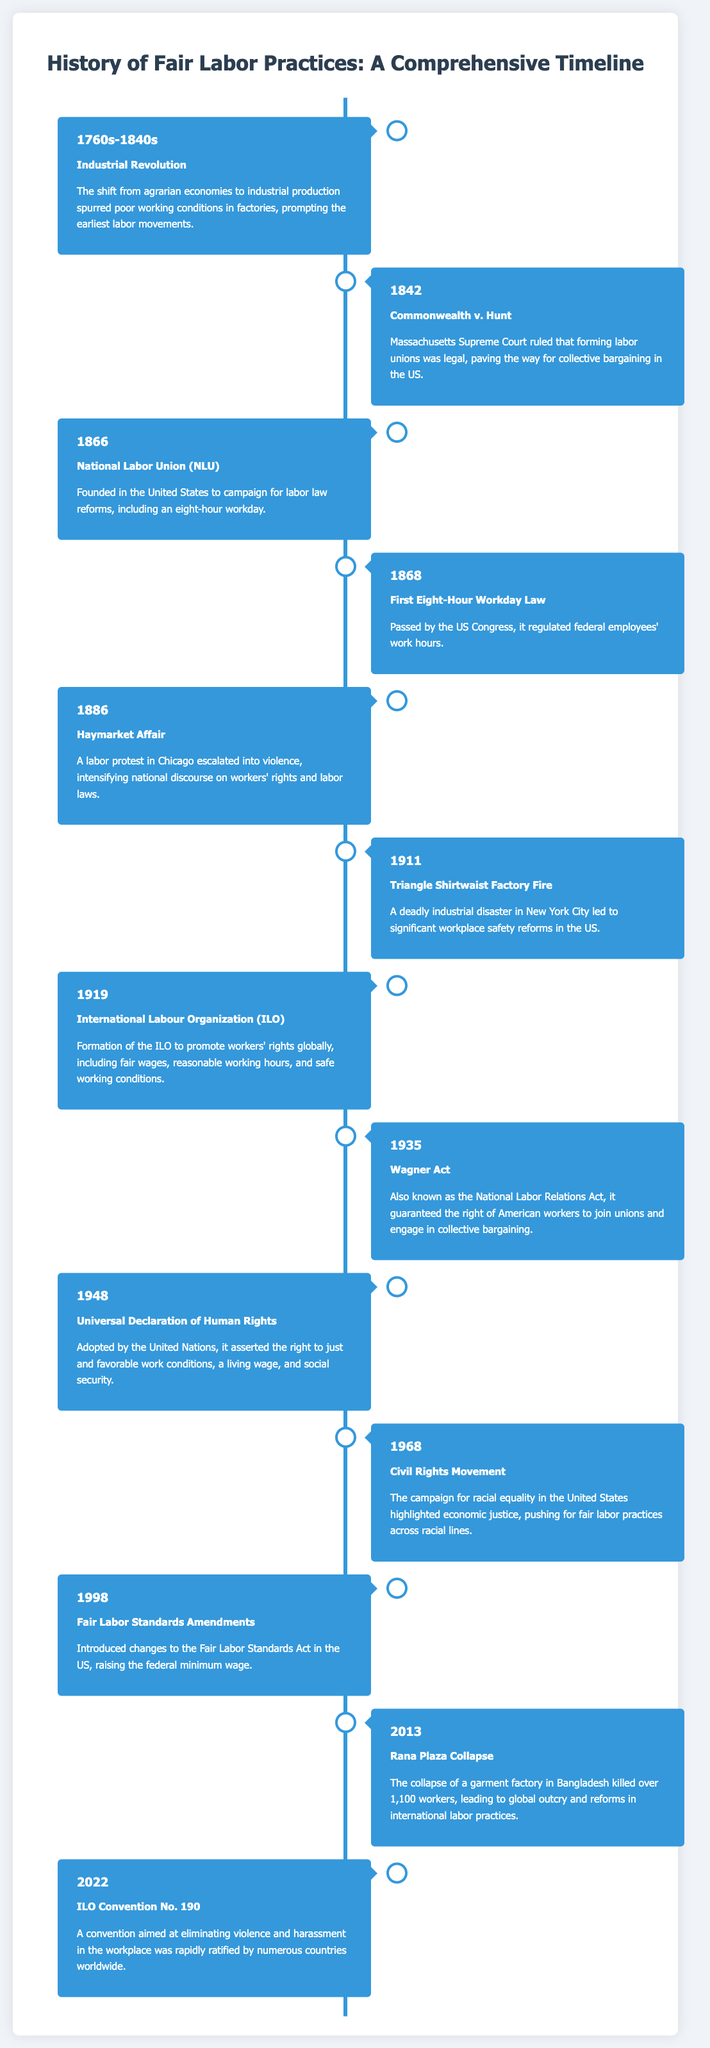What year did the Triangle Shirtwaist Factory Fire occur? The document lists the Triangle Shirtwaist Factory Fire in the year 1911.
Answer: 1911 What was the focus of the National Labor Union founded in 1866? The National Labor Union was focused on campaigning for labor law reforms, including an eight-hour workday.
Answer: Eight-hour workday Which event led to significant workplace safety reforms in the US? The Triangle Shirtwaist Factory Fire led to significant workplace safety reforms in the US according to the document.
Answer: Triangle Shirtwaist Factory Fire What legislation was passed in 1935 to guarantee workers' rights to unionize? The document indicates that the Wagner Act, also known as the National Labor Relations Act, was passed in 1935.
Answer: Wagner Act What international organization was formed in 1919? The International Labour Organization (ILO) was formed in 1919 as stated in the timeline.
Answer: International Labour Organization Which event in 2013 raised awareness of labor conditions worldwide? The Rana Plaza Collapse in Bangladesh caused global outcry and highlighted labor conditions.
Answer: Rana Plaza Collapse What does ILO Convention No. 190 aim to eliminate? The convention aims to eliminate violence and harassment in the workplace.
Answer: Violence and harassment What fundamental right was asserted in the Universal Declaration of Human Rights adopted in 1948? The document states that the Universal Declaration asserted the right to just and favorable work conditions.
Answer: Just and favorable work conditions 